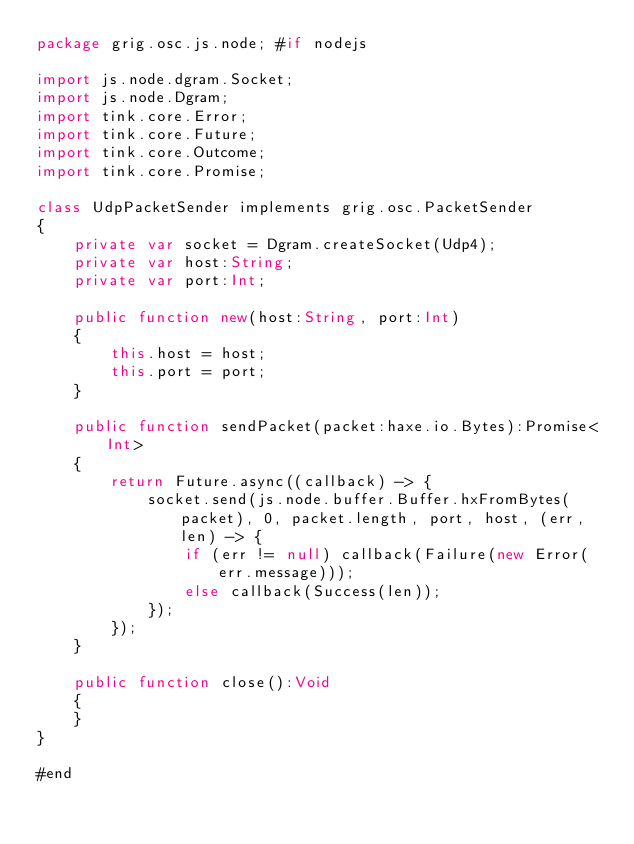<code> <loc_0><loc_0><loc_500><loc_500><_Haxe_>package grig.osc.js.node; #if nodejs

import js.node.dgram.Socket;
import js.node.Dgram;
import tink.core.Error;
import tink.core.Future;
import tink.core.Outcome;
import tink.core.Promise;

class UdpPacketSender implements grig.osc.PacketSender
{
    private var socket = Dgram.createSocket(Udp4);
    private var host:String;
    private var port:Int;

    public function new(host:String, port:Int)
    {
        this.host = host;
        this.port = port;
    }

    public function sendPacket(packet:haxe.io.Bytes):Promise<Int>
    {
        return Future.async((callback) -> {
            socket.send(js.node.buffer.Buffer.hxFromBytes(packet), 0, packet.length, port, host, (err, len) -> {
                if (err != null) callback(Failure(new Error(err.message)));
                else callback(Success(len));
            });
        });
    }

    public function close():Void
    {
    }
}

#end</code> 